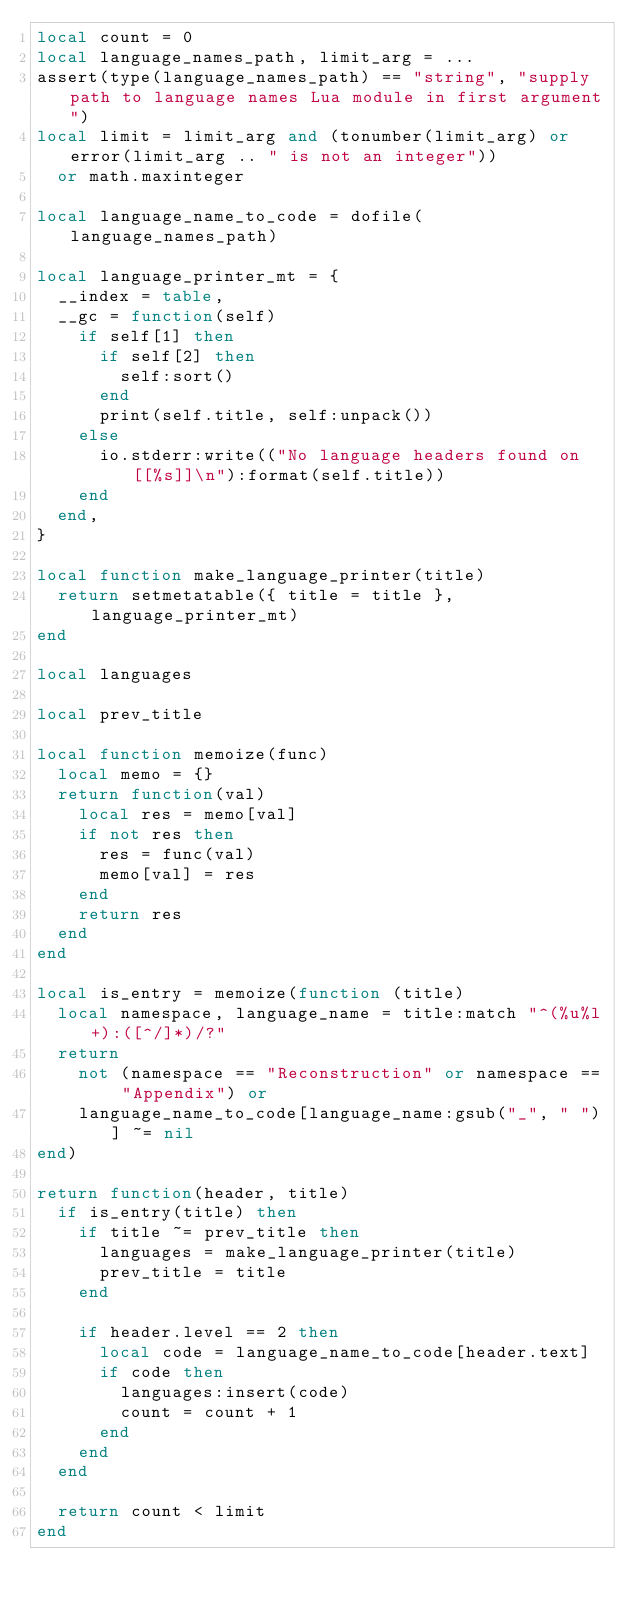<code> <loc_0><loc_0><loc_500><loc_500><_Lua_>local count = 0
local language_names_path, limit_arg = ...
assert(type(language_names_path) == "string", "supply path to language names Lua module in first argument")
local limit = limit_arg and (tonumber(limit_arg) or error(limit_arg .. " is not an integer"))
	or math.maxinteger

local language_name_to_code = dofile(language_names_path)

local language_printer_mt = {
	__index = table,
	__gc = function(self)
		if self[1] then
			if self[2] then
				self:sort()
			end
			print(self.title, self:unpack())
		else
			io.stderr:write(("No language headers found on [[%s]]\n"):format(self.title))
		end
	end,
}

local function make_language_printer(title)
	return setmetatable({ title = title }, language_printer_mt)
end

local languages

local prev_title

local function memoize(func)
	local memo = {}
	return function(val)
		local res = memo[val]
		if not res then
			res = func(val)
			memo[val] = res
		end
		return res
	end
end

local is_entry = memoize(function (title)
	local namespace, language_name = title:match "^(%u%l+):([^/]*)/?"
	return
		not (namespace == "Reconstruction" or namespace == "Appendix") or
		language_name_to_code[language_name:gsub("_", " ")] ~= nil
end)

return function(header, title)
	if is_entry(title) then
		if title ~= prev_title then
			languages = make_language_printer(title)
			prev_title = title
		end
		
		if header.level == 2 then
			local code = language_name_to_code[header.text]
			if code then
				languages:insert(code)
				count = count + 1
			end
		end
	end
	
	return count < limit
end
</code> 